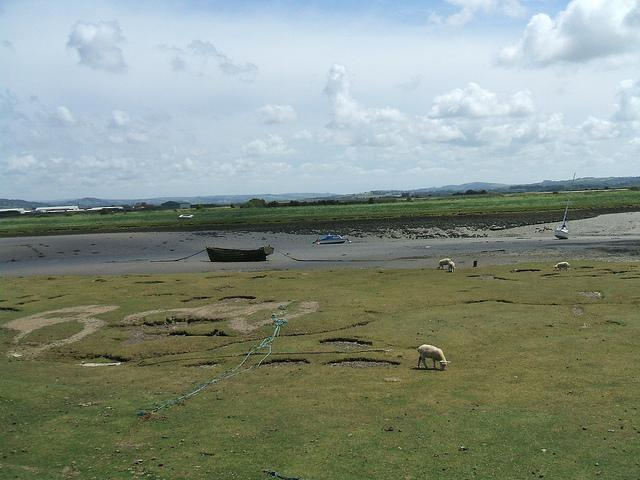What has dried up and stopped the boats from moving?

Choices:
A) water
B) grass
C) ice
D) clouds water 